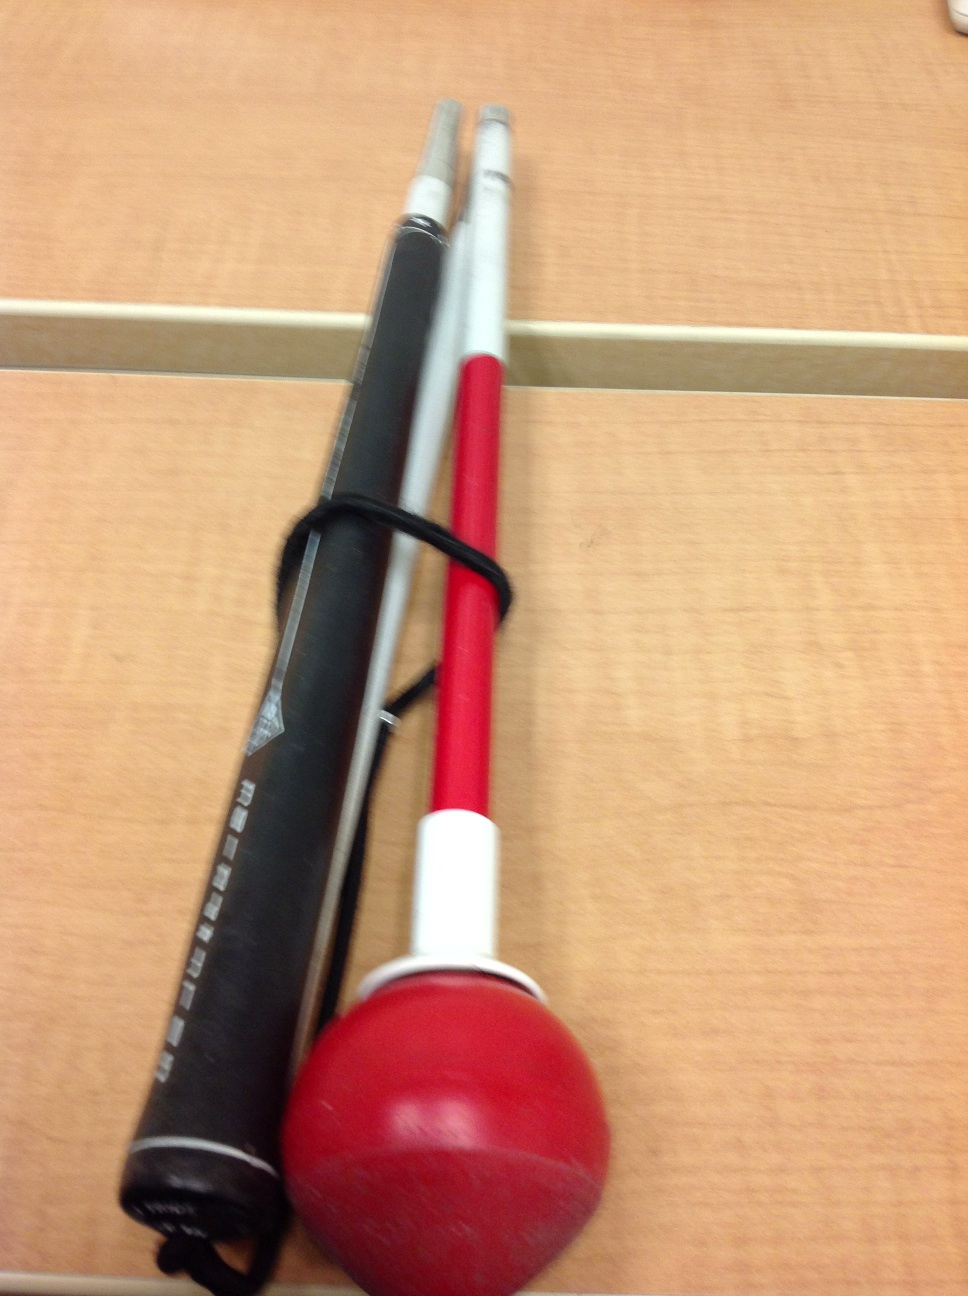How would you use this tool during training? During training, a player would attach the swing trainer to their bat, taking their normal batting stance. They would then perform repeated swings, focusing on technique, to build muscle memory. Coaches often incorporate it into hitting drills to ensure consistency and proper form. Can this help prevent common batting mistakes? Absolutely. The instant feedback from the resistance helps in correcting common mistakes such as dropping the bat's shoulder or overextending. It encourages a compact, efficient swing path directly to the ball. 